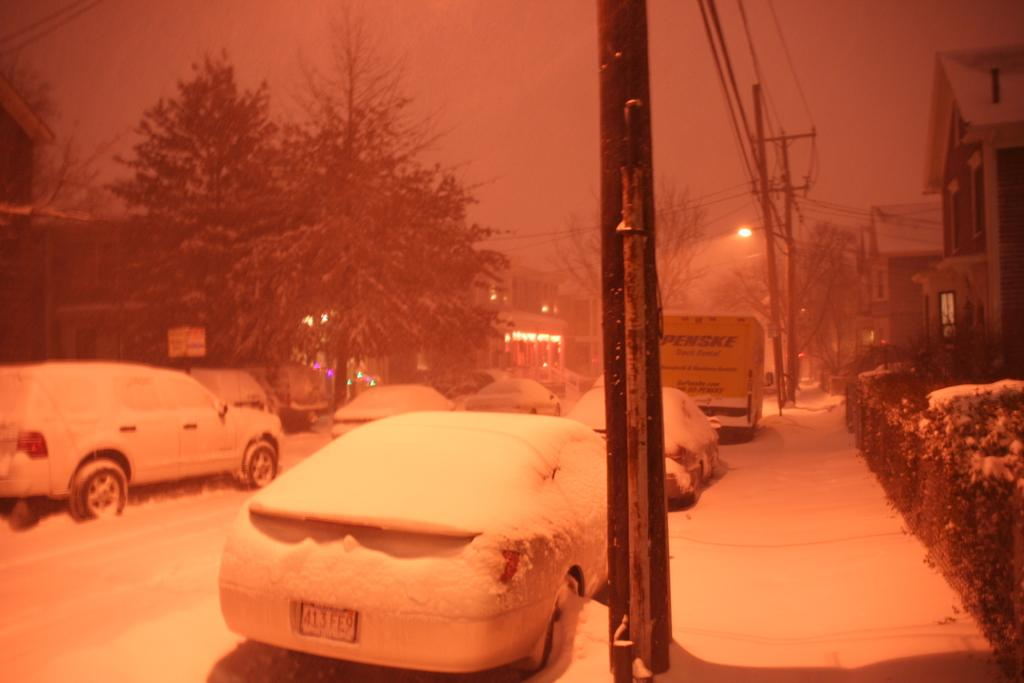What can be seen on the road in the image? There are many cars parked on the road in the image. What is the weather like in the image? There is snow visible in the image, indicating a snowy or cold weather condition. What can be seen in the background of the image? There are trees and poles in the background of the image. What type of structures are on the right side of the image? There are buildings on the right side of the image. What type of grain can be seen growing in the image? There is no grain visible in the image; it features cars parked on a snowy road with trees, poles, and buildings in the background. What sound can be heard coming from the sea in the image? There is no sea or any sound associated with it in the image. 